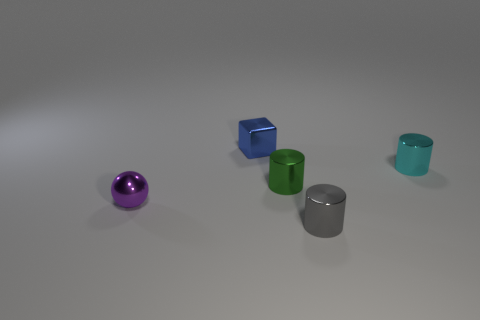Does the gray shiny cylinder have the same size as the cyan metal cylinder on the right side of the purple metallic ball?
Offer a terse response. Yes. What number of things are tiny green cylinders that are on the right side of the small sphere or small cylinders that are behind the ball?
Give a very brief answer. 2. There is a purple object that is the same size as the blue thing; what shape is it?
Keep it short and to the point. Sphere. There is a tiny metallic thing that is on the left side of the metallic object that is behind the tiny cylinder that is behind the small green metal cylinder; what is its shape?
Make the answer very short. Sphere. Are there an equal number of blocks on the right side of the blue block and metal cubes?
Give a very brief answer. No. Do the gray metal object and the cyan cylinder have the same size?
Your response must be concise. Yes. What number of metal things are either tiny things or blue cubes?
Your response must be concise. 5. There is a blue cube that is the same size as the green metal cylinder; what material is it?
Offer a very short reply. Metal. What number of other objects are the same material as the tiny sphere?
Keep it short and to the point. 4. Are there fewer small cyan cylinders to the left of the tiny blue thing than cylinders?
Provide a succinct answer. Yes. 